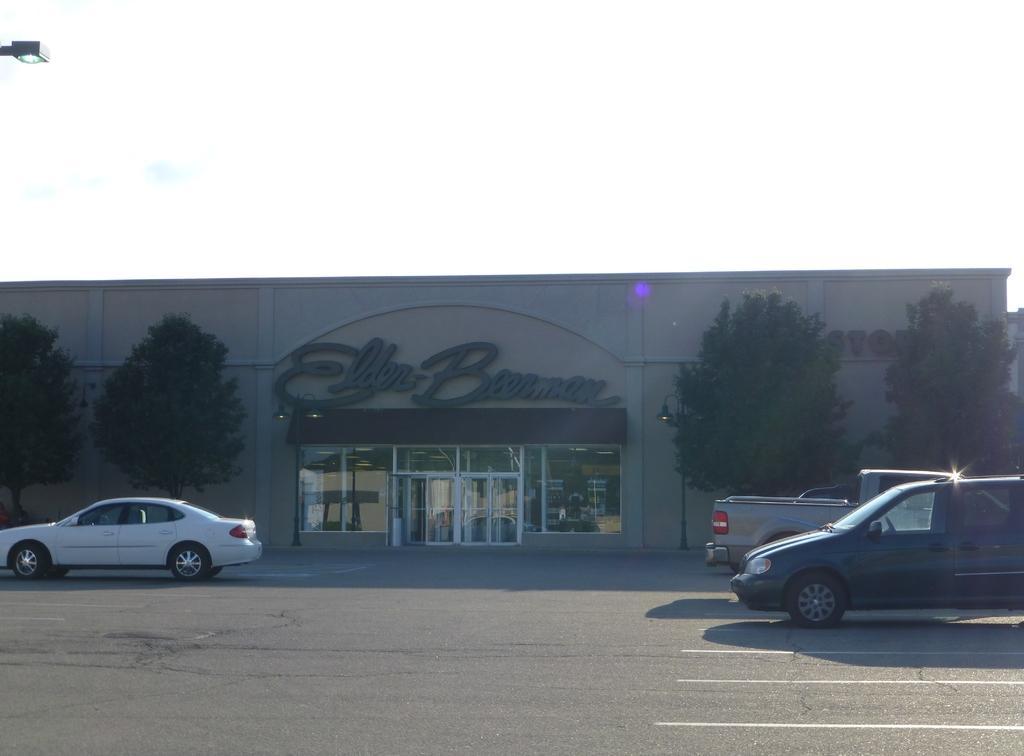How would you summarize this image in a sentence or two? In the image in the center, we can see a few vehicles on the road. In the background, we can see the sky, clouds, trees, one building, wall, banner, glass etc. 